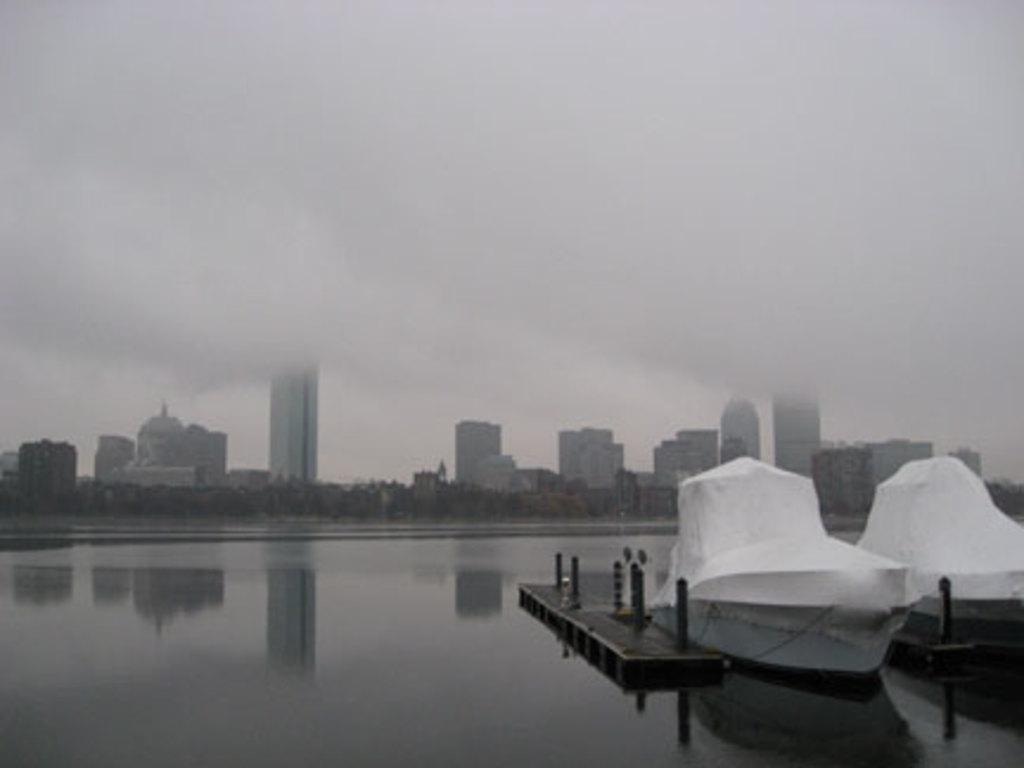What can be seen in the water in the foreground of the image? There are boats in the water in the foreground of the image. What is located near the water in the foreground of the image? There is a fence in the foreground of the image. What type of vegetation is visible in the background of the image? There are trees in the background of the image. What type of structures can be seen in the background of the image? There are buildings in the background of the image. What part of the natural environment is visible in the background of the image? The sky is visible in the background of the image. Can you determine the time of day the image was taken? The image was likely taken during the day, as the sky is visible and there is no indication of darkness. What type of brick is used to build the pear in the image? There is no pear or brick present in the image. Can you describe the lipstick color of the person in the image? There are no people or lipstick present in the image. 